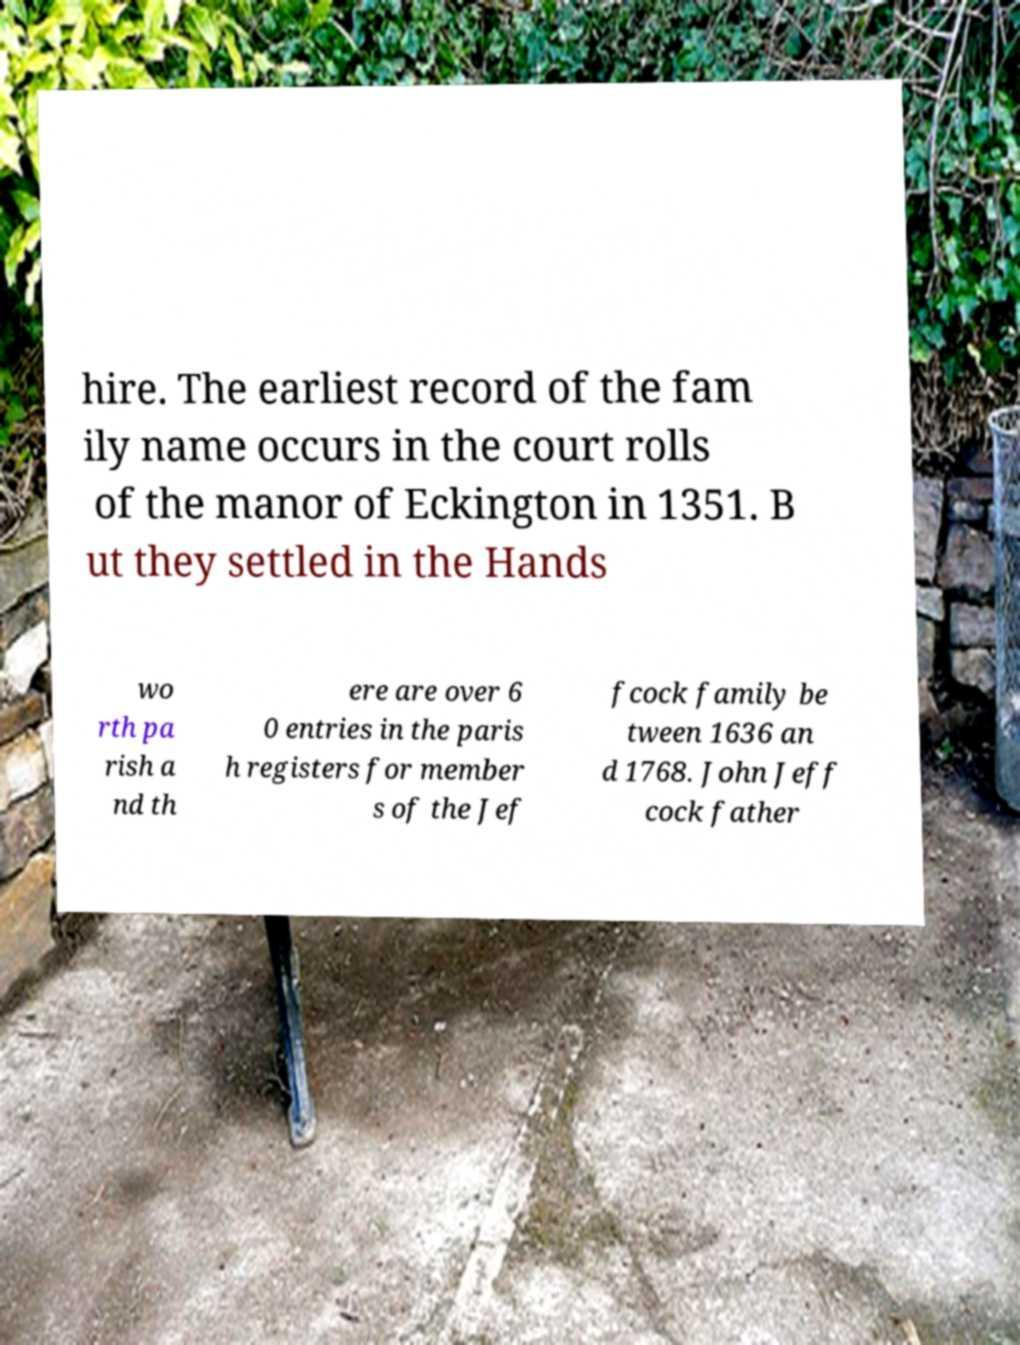I need the written content from this picture converted into text. Can you do that? hire. The earliest record of the fam ily name occurs in the court rolls of the manor of Eckington in 1351. B ut they settled in the Hands wo rth pa rish a nd th ere are over 6 0 entries in the paris h registers for member s of the Jef fcock family be tween 1636 an d 1768. John Jeff cock father 